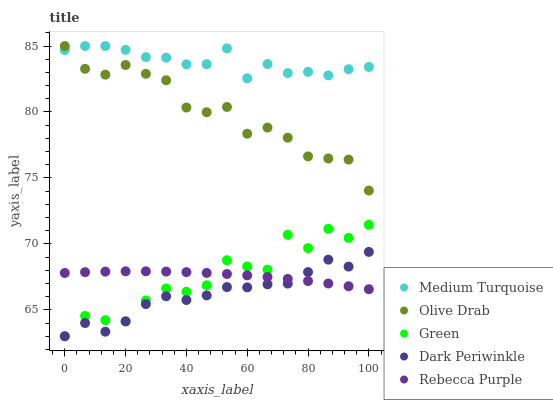Does Dark Periwinkle have the minimum area under the curve?
Answer yes or no. Yes. Does Medium Turquoise have the maximum area under the curve?
Answer yes or no. Yes. Does Green have the minimum area under the curve?
Answer yes or no. No. Does Green have the maximum area under the curve?
Answer yes or no. No. Is Rebecca Purple the smoothest?
Answer yes or no. Yes. Is Green the roughest?
Answer yes or no. Yes. Is Olive Drab the smoothest?
Answer yes or no. No. Is Olive Drab the roughest?
Answer yes or no. No. Does Green have the lowest value?
Answer yes or no. Yes. Does Olive Drab have the lowest value?
Answer yes or no. No. Does Medium Turquoise have the highest value?
Answer yes or no. Yes. Does Green have the highest value?
Answer yes or no. No. Is Dark Periwinkle less than Medium Turquoise?
Answer yes or no. Yes. Is Olive Drab greater than Rebecca Purple?
Answer yes or no. Yes. Does Green intersect Rebecca Purple?
Answer yes or no. Yes. Is Green less than Rebecca Purple?
Answer yes or no. No. Is Green greater than Rebecca Purple?
Answer yes or no. No. Does Dark Periwinkle intersect Medium Turquoise?
Answer yes or no. No. 